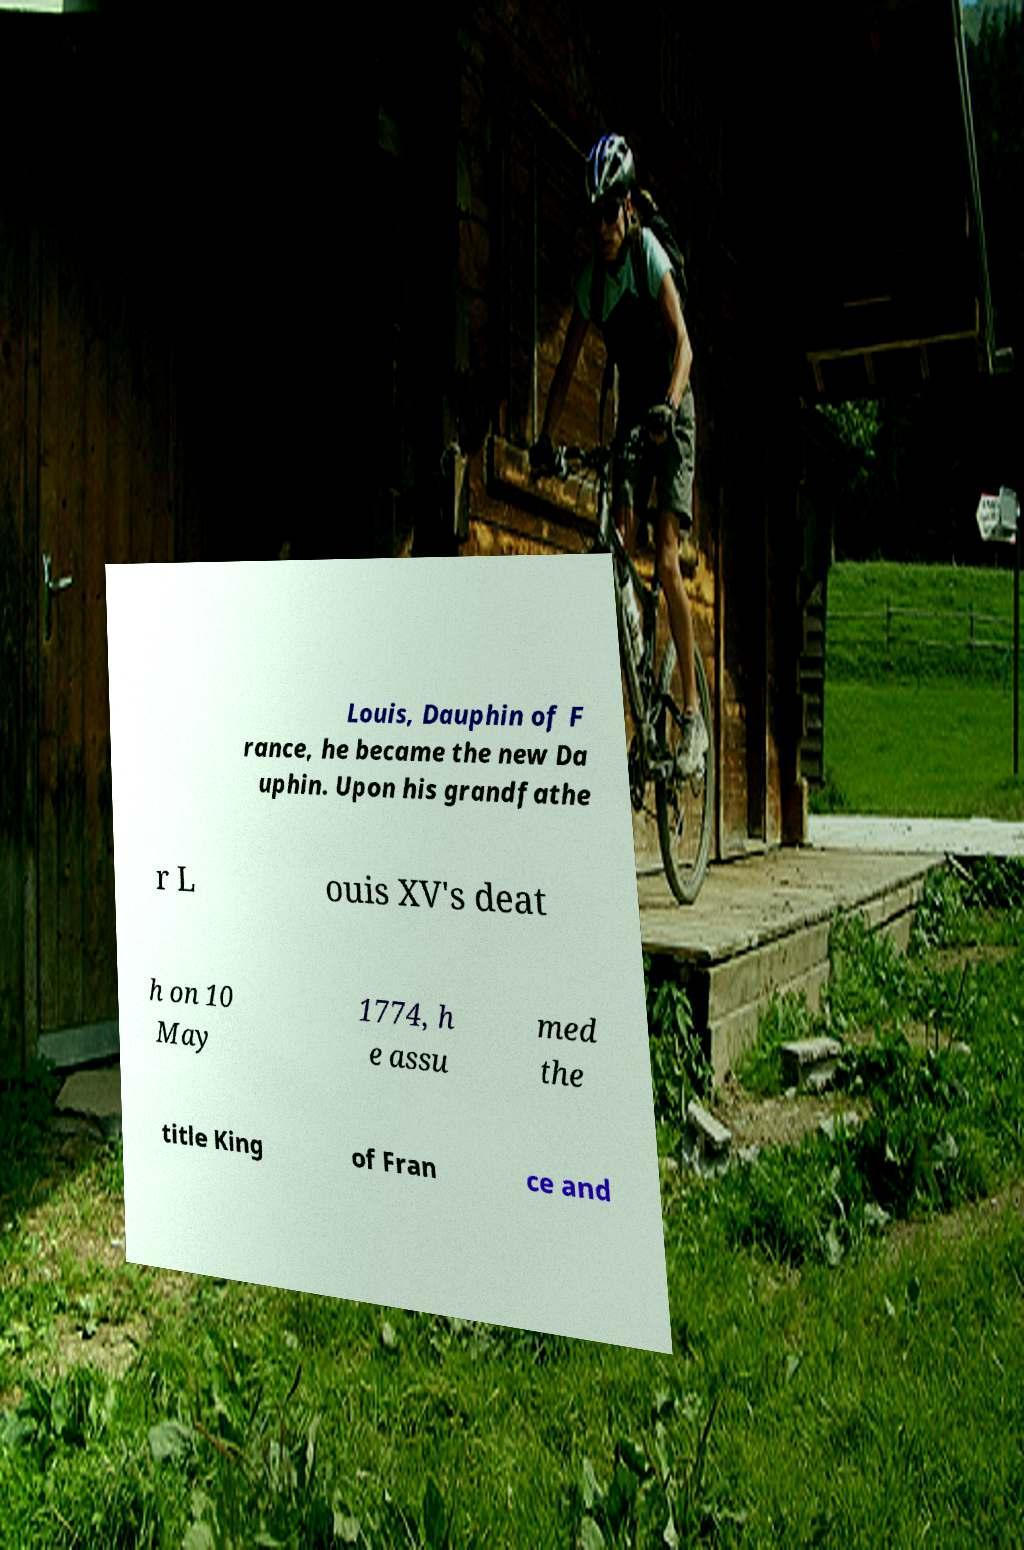Could you extract and type out the text from this image? Louis, Dauphin of F rance, he became the new Da uphin. Upon his grandfathe r L ouis XV's deat h on 10 May 1774, h e assu med the title King of Fran ce and 